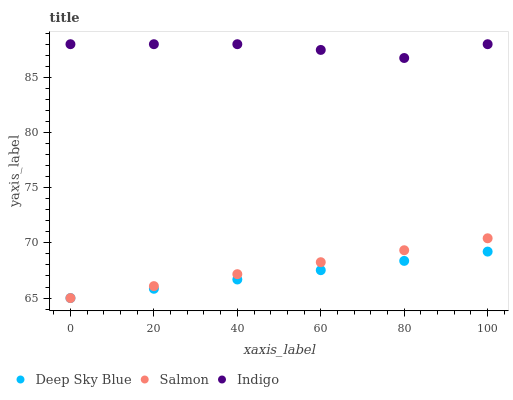Does Deep Sky Blue have the minimum area under the curve?
Answer yes or no. Yes. Does Indigo have the maximum area under the curve?
Answer yes or no. Yes. Does Salmon have the minimum area under the curve?
Answer yes or no. No. Does Salmon have the maximum area under the curve?
Answer yes or no. No. Is Deep Sky Blue the smoothest?
Answer yes or no. Yes. Is Indigo the roughest?
Answer yes or no. Yes. Is Salmon the smoothest?
Answer yes or no. No. Is Salmon the roughest?
Answer yes or no. No. Does Salmon have the lowest value?
Answer yes or no. Yes. Does Indigo have the highest value?
Answer yes or no. Yes. Does Salmon have the highest value?
Answer yes or no. No. Is Deep Sky Blue less than Indigo?
Answer yes or no. Yes. Is Indigo greater than Salmon?
Answer yes or no. Yes. Does Salmon intersect Deep Sky Blue?
Answer yes or no. Yes. Is Salmon less than Deep Sky Blue?
Answer yes or no. No. Is Salmon greater than Deep Sky Blue?
Answer yes or no. No. Does Deep Sky Blue intersect Indigo?
Answer yes or no. No. 